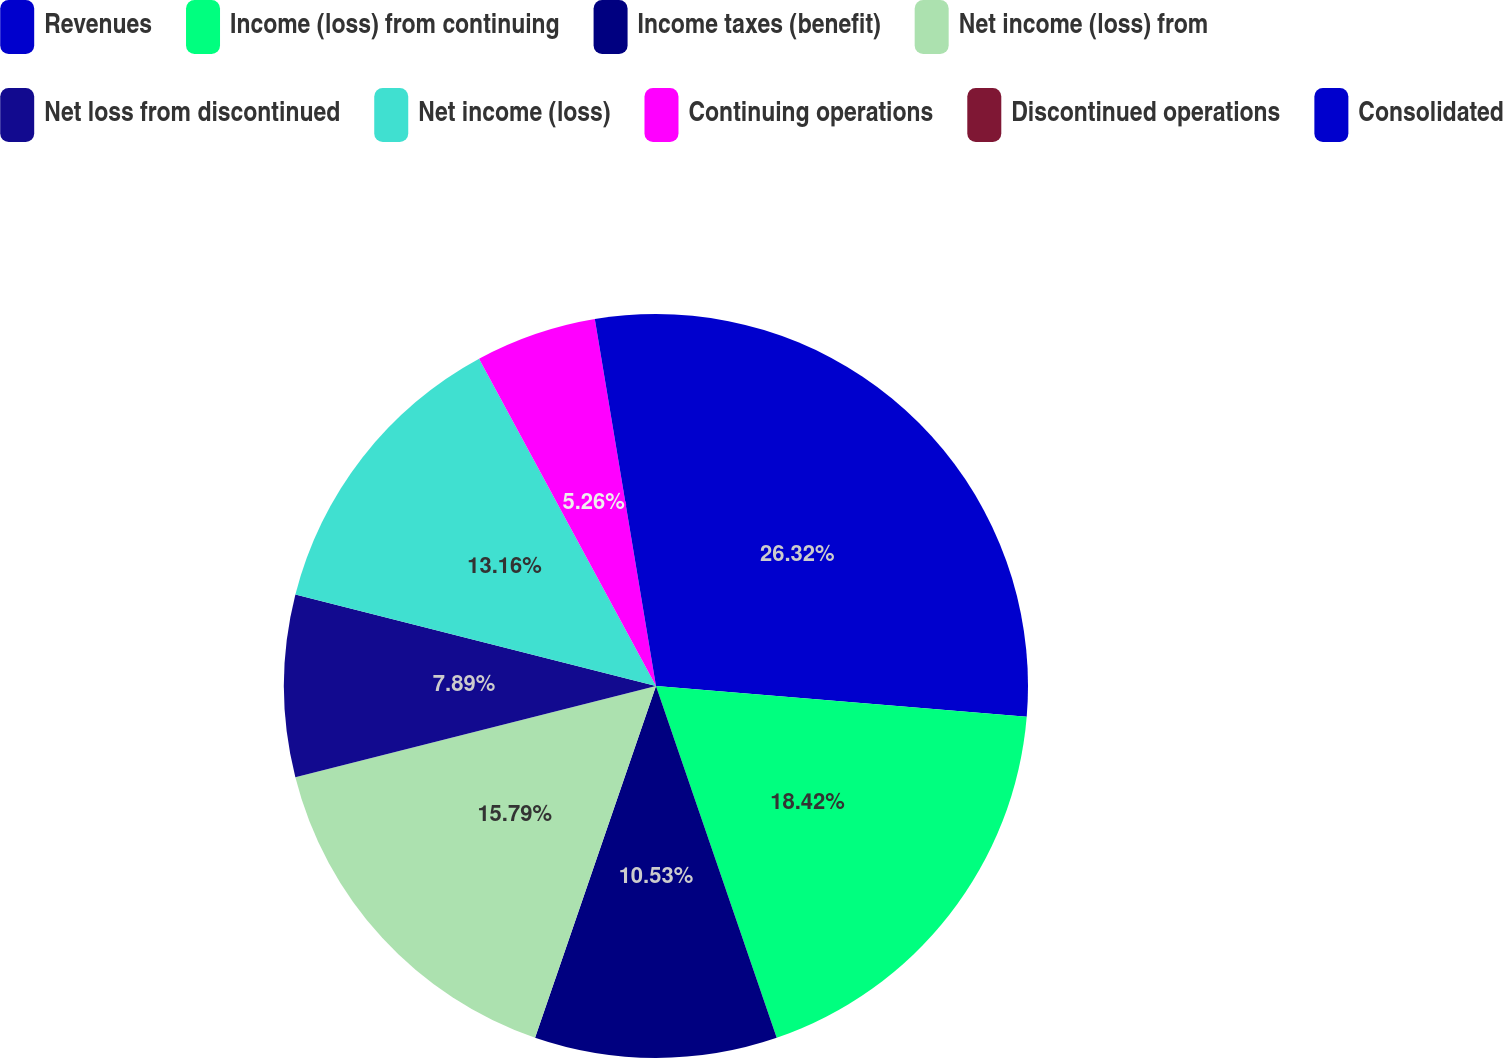Convert chart. <chart><loc_0><loc_0><loc_500><loc_500><pie_chart><fcel>Revenues<fcel>Income (loss) from continuing<fcel>Income taxes (benefit)<fcel>Net income (loss) from<fcel>Net loss from discontinued<fcel>Net income (loss)<fcel>Continuing operations<fcel>Discontinued operations<fcel>Consolidated<nl><fcel>26.32%<fcel>18.42%<fcel>10.53%<fcel>15.79%<fcel>7.89%<fcel>13.16%<fcel>5.26%<fcel>0.0%<fcel>2.63%<nl></chart> 